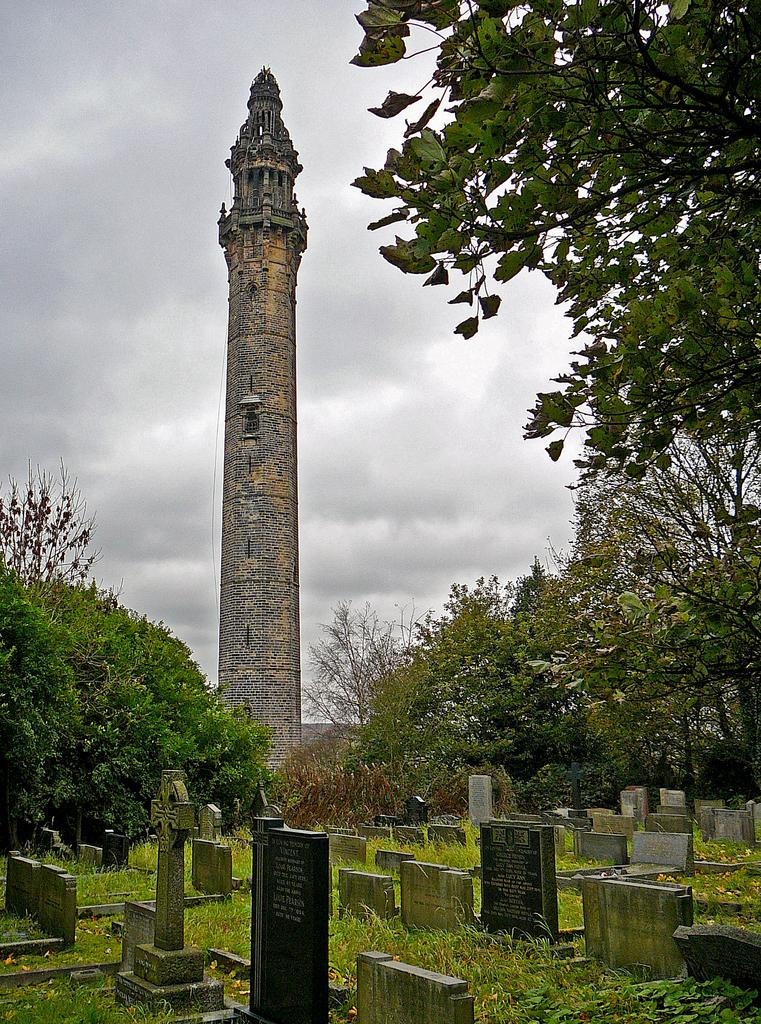What type of landscape is depicted at the bottom of the image? Cemeteries, grass, and trees are present at the bottom of the image. What can be seen in the background of the image? There is a tower, walls, and a cloudy sky in the background of the image. What is the taste of the air in the image? There is no mention of air or taste in the image, so it cannot be determined. Can you describe the crack in the tower in the image? There is no crack mentioned in the tower in the image. 